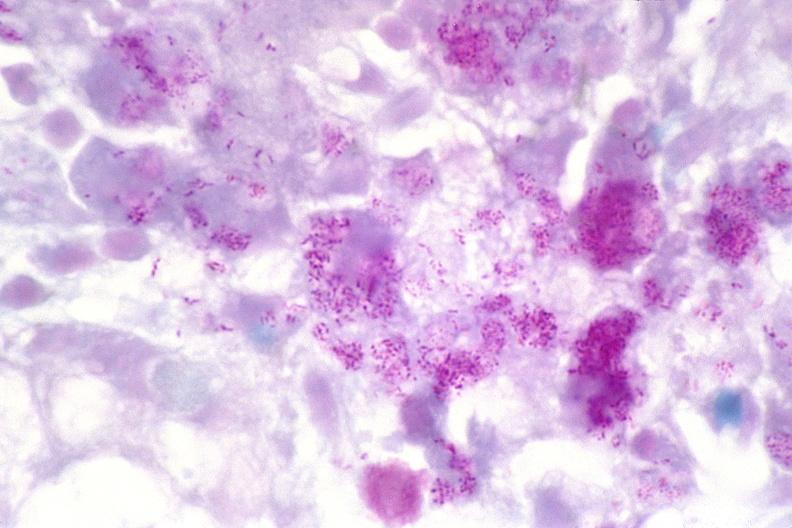does this image show lymph node, mycobacterium avium-intracellularae?
Answer the question using a single word or phrase. Yes 